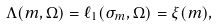Convert formula to latex. <formula><loc_0><loc_0><loc_500><loc_500>\Lambda ( m , \Omega ) = \ell _ { 1 } ( \sigma _ { m } , \Omega ) = \xi ( m ) ,</formula> 